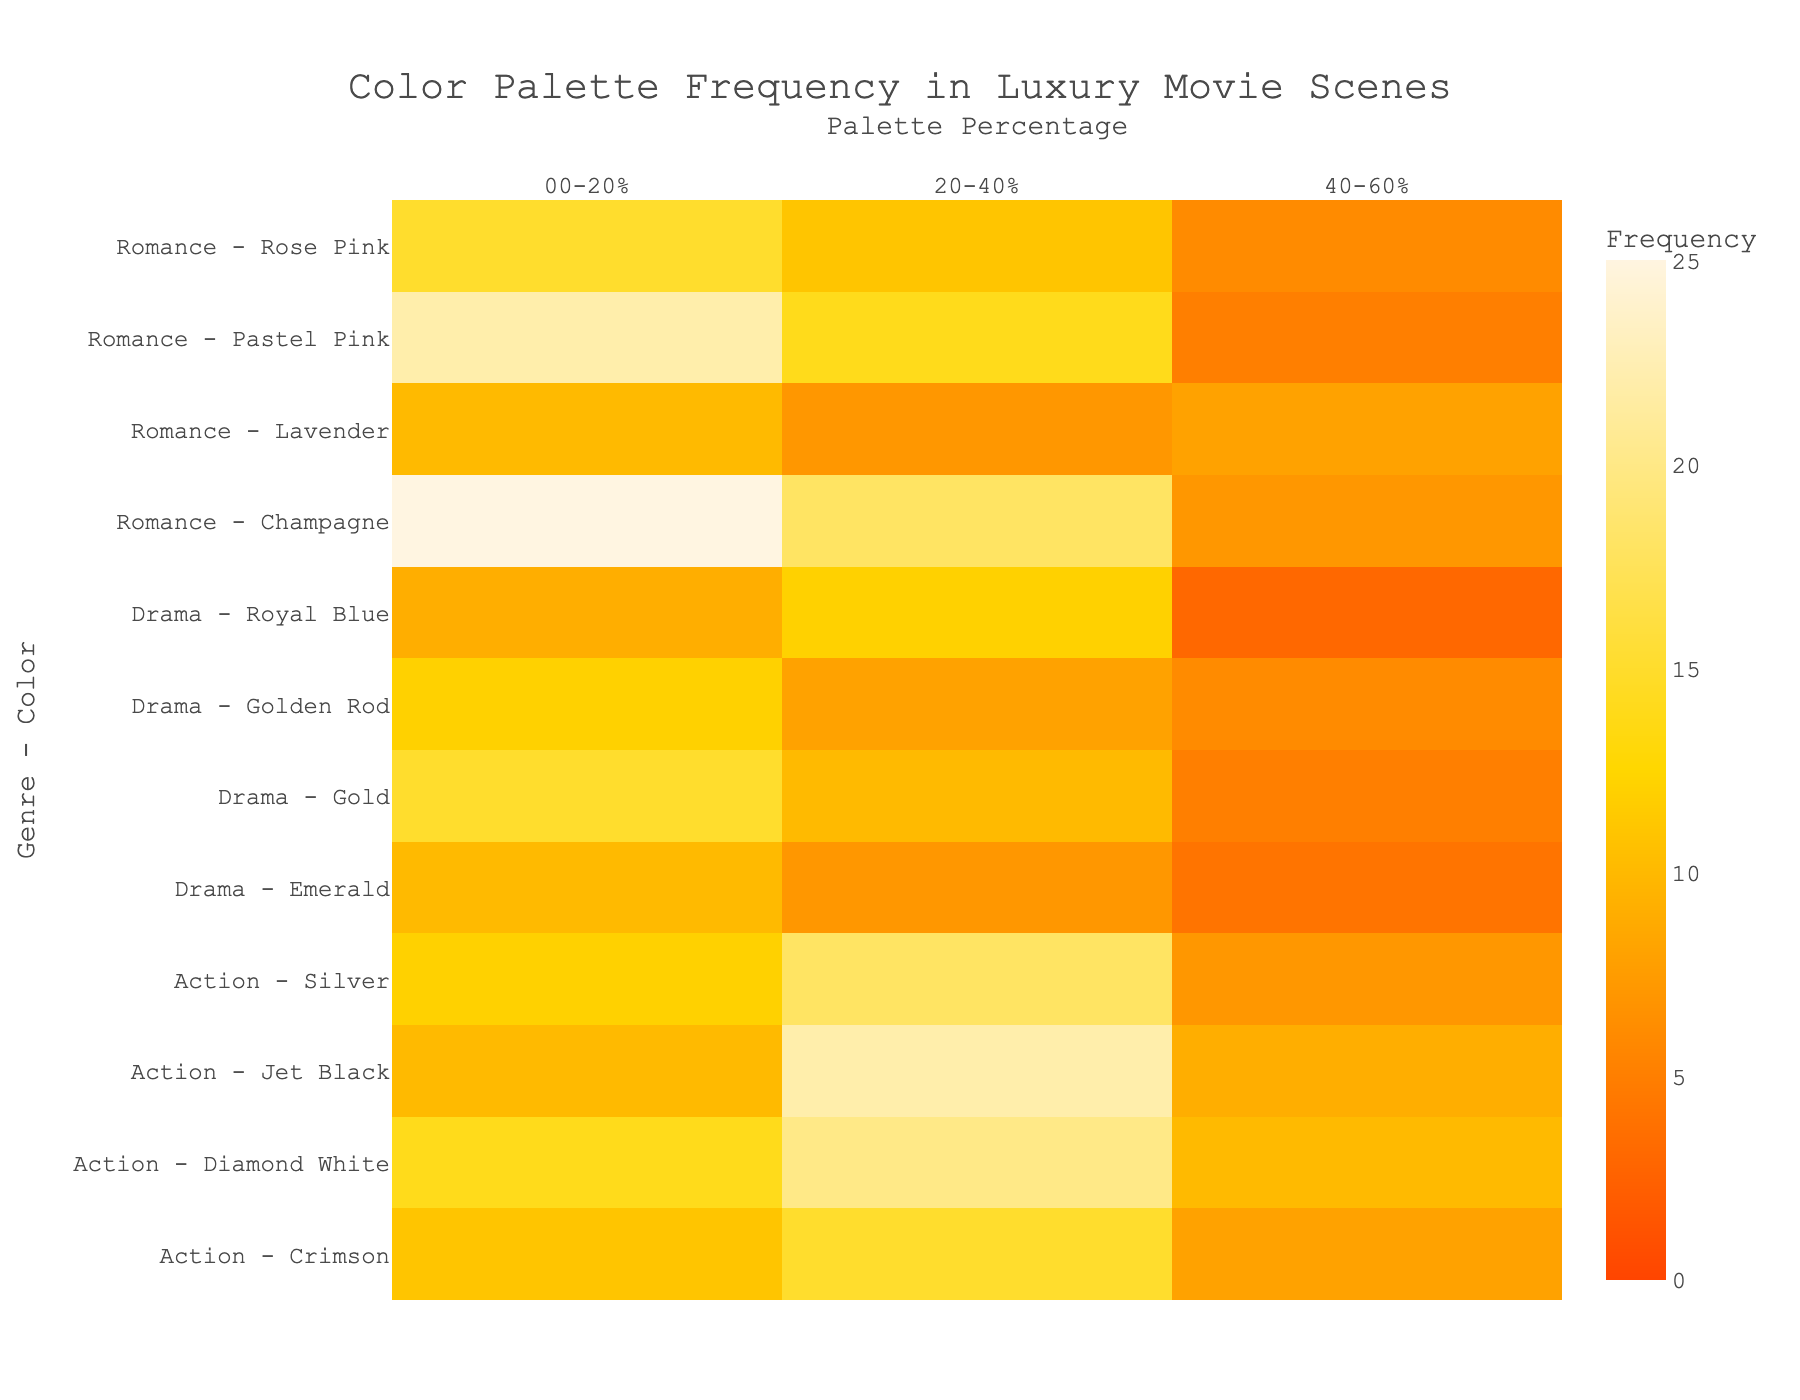What is the title of the heatmap? The title can be found at the top of the plot, typically centered and formatted larger than other text. It reads "Color Palette Frequency in Luxury Movie Scenes."
Answer: Color Palette Frequency in Luxury Movie Scenes Which genre and color combination has the highest frequency in the 00-20% palette range? Looking at the heatmap's color intensity and the 00-20% palette range, the combination with the highest frequency is "Romance - Champagne," indicated by the darkest color shade.
Answer: Romance - Champagne What is the frequency of the Silver color in Action movies for the 20-40% palette? On the Y-axis, locate "Action - Silver" and intersect it with the 20-40% column on the X-axis to find the value. The frequency is 18.
Answer: 18 How many distinct color-palette frequency points are shown in the heatmap? Each cell in the heatmap represents a frequency point for a specific genre-color combination and palette percentage. Counting those cells gives the total frequency points: 36 rows (9 genre-color combinations) x 3 columns (palette percentages) = 36 points.
Answer: 36 Which genre uses the Gold color most frequently in the 00-20% palette range, and what is the frequency? Locate the rows for "Drama - Gold" in the 00-20% palette range column. The frequency indicated by the color shade is 15.
Answer: Drama, 15 Compare the frequency of Royal Blue in Drama movies for the 20-40% and 40-60% palettes. Which is higher and by how much? Find the values for Royal Blue in Drama movies in the 20-40% and 40-60% rows. The frequencies are 12 and 3, respectively. The frequency for the 20-40% palette is higher by 9.
Answer: 20-40%, higher by 9 What is the combined frequency of Emerald color in Drama movies across all palette percentages? Sum the frequencies of "Drama - Emerald" for 00-20%, 20-40%, and 40-60%: 10 + 7 + 4 = 21.
Answer: 21 Which palette percentage range has the lowest combined frequency for Jet Black in Action movies? The frequencies for Jet Black in Action movies are 10 (00-20%), 22 (20-40%), and 9 (40-60%). The 40-60% range has the lowest combined frequency.
Answer: 40-60% Interpret the use of pastel shades in Romance scenes. Which pastel shade is used most frequently and in which palette range? In Romance scenes, locate the pastel shades like Rose Pink and Pastel Pink in the heatmap. Pastel Pink in the 00-20% palette range has the highest frequency at 22.
Answer: Pastel Pink, 00-20% 